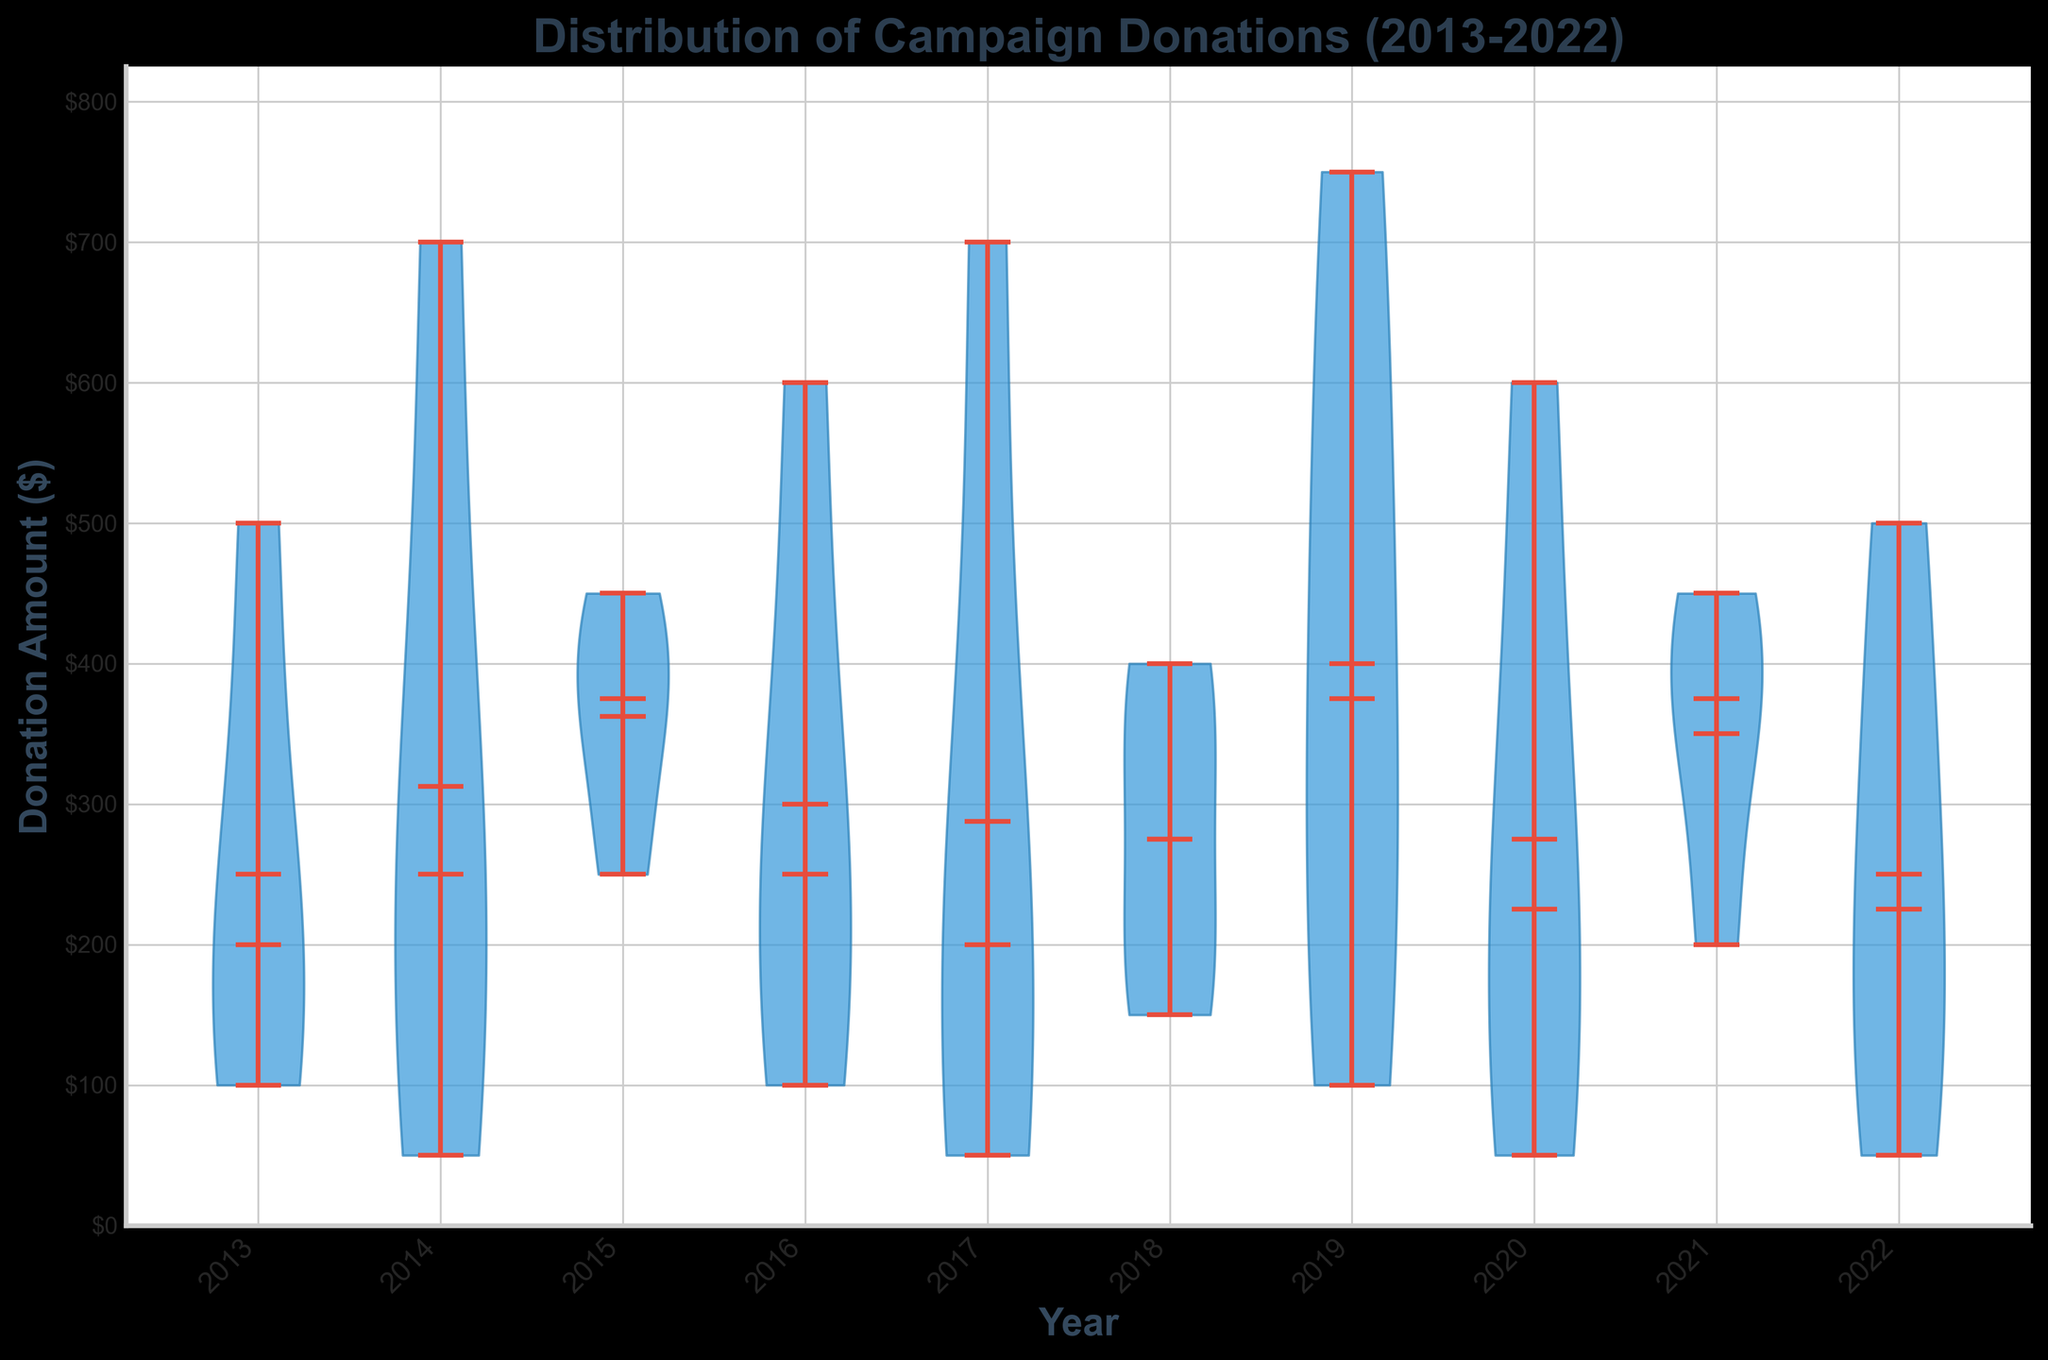What is the title of the plot? The title of the plot is usually displayed at the top of the figure and is often bold to stand out. By looking at the figure, the title "Distribution of Campaign Donations (2013-2022)" is clearly visible.
Answer: Distribution of Campaign Donations (2013-2022) How are the axes labeled? The labels on the axes usually provide information about what data is being represented. On the figure, the x-axis is labeled as "Year" and the y-axis is labeled as "Donation Amount ($)."
Answer: x-axis: Year, y-axis: Donation Amount ($) What year has the highest median donation amount? The median value is usually indicated on a violin plot with a line. By comparing the medians across different years, 2014 and 2017 have the highest median donation amount as seen by the placement of the median lines.
Answer: 2014 and 2017 Which year has the widest range of donation amounts? The range of donation amounts can be determined by comparing the highest and lowest points on each violin plot. The year 2019 has the widest range, shown by the spread from the minimum to the maximum donation.
Answer: 2019 What is the mean donation amount for the year 2020? The mean is often represented by a dashed line or marker in the violin plot. By checking the plot, the mean donation amount for 2020 is around $275.
Answer: Approximately $275 In which year is the lowest donation amount located? The lowest donation amount is typically shown at the bottom of each violin plot. The figure indicates that the lowest donation amount of $50 appears in multiple years such as 2014, 2017, 2020, and 2022.
Answer: 2014, 2017, 2020, and 2022 Which year has the highest mean donation amount? The mean donation amount is indicated by a dashed line in each violin plot. By comparing the alignment of these dashed lines, 2019 has the highest mean donation amount.
Answer: 2019 How does the donation distribution in 2013 compare to 2014? To compare distributions, we can look at the spread and shape of the violins. The distribution in 2013 is narrower and has a lower median and mean compared to 2014, which shows a wider distribution and higher values.
Answer: 2014 has a wider distribution with higher median and mean amounts What is the trend of donation amounts from 2013 to 2022? Observing the medians, means, and ranges over the years, the plot shows that donation amounts generally increase from 2013 to 2019, drop slightly around 2020 and 2021, but remain relatively high overall by 2022.
Answer: General increase with a peak around 2019 and slight drop around 2020-2021 What can be inferred about the consistency of donations over the years? Consistency can be measured by the tightness of the distribution around the median and mean. Years like 2014 and 2017 show a high consistency with narrow distributions, while others like 2019 have wider distributions, indicating larger variability in donations.
Answer: Donor consistency varies, with some years showing more variability in donation amounts 